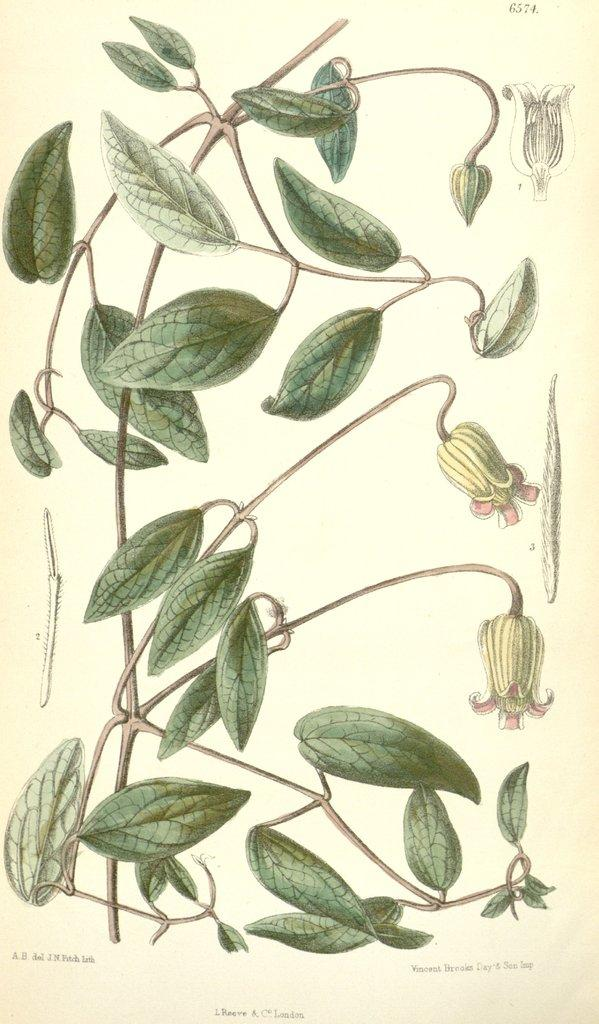What is depicted in the painting in the image? The painting contains stems with leaves and flowers. What else can be seen on the image besides the painting? There is text present on the image. What type of engine is depicted in the painting? There is no engine present in the painting; it features stems with leaves and flowers. What is the end result of the care provided to the flowers in the painting? The image is a painting and does not depict real flowers or their care, so it is not possible to determine the end result of any care provided. 